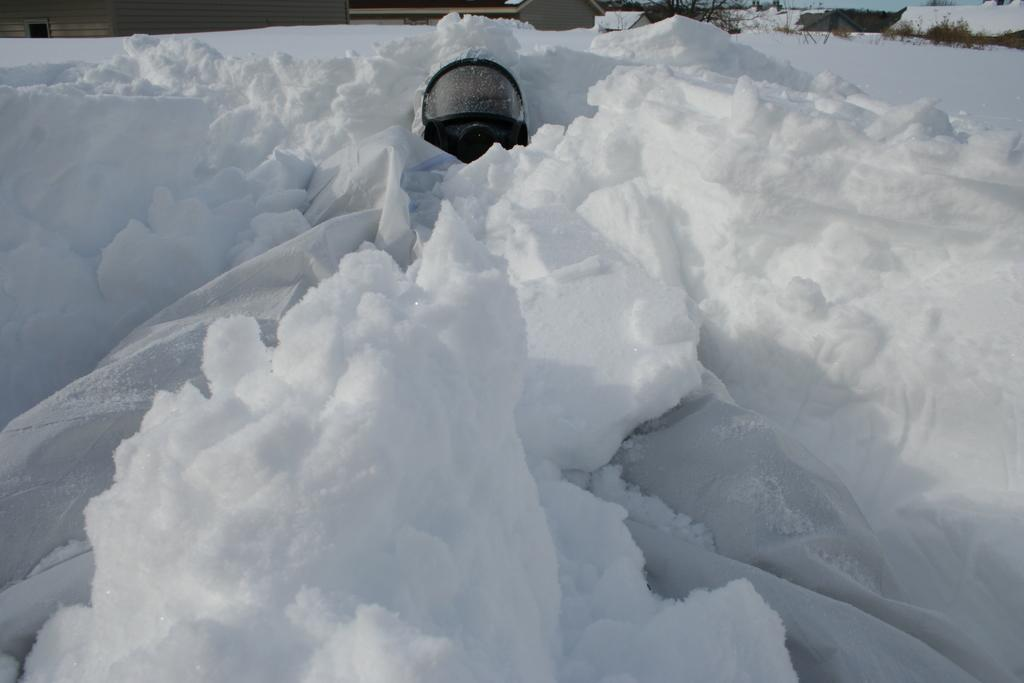What is the main object on the snow in the image? There is an object on the snow in the image, but the specific object is not mentioned in the facts. What structures can be seen in the image? There are buildings in the image. What type of vegetation is visible in the background of the image? There are trees in the background of the image. What is visible in the sky in the image? The sky is visible in the background of the image. How many lizards can be seen walking on the snow in the image? There are no lizards visible in the image; it features an object on the snow, buildings, trees, and the sky. 